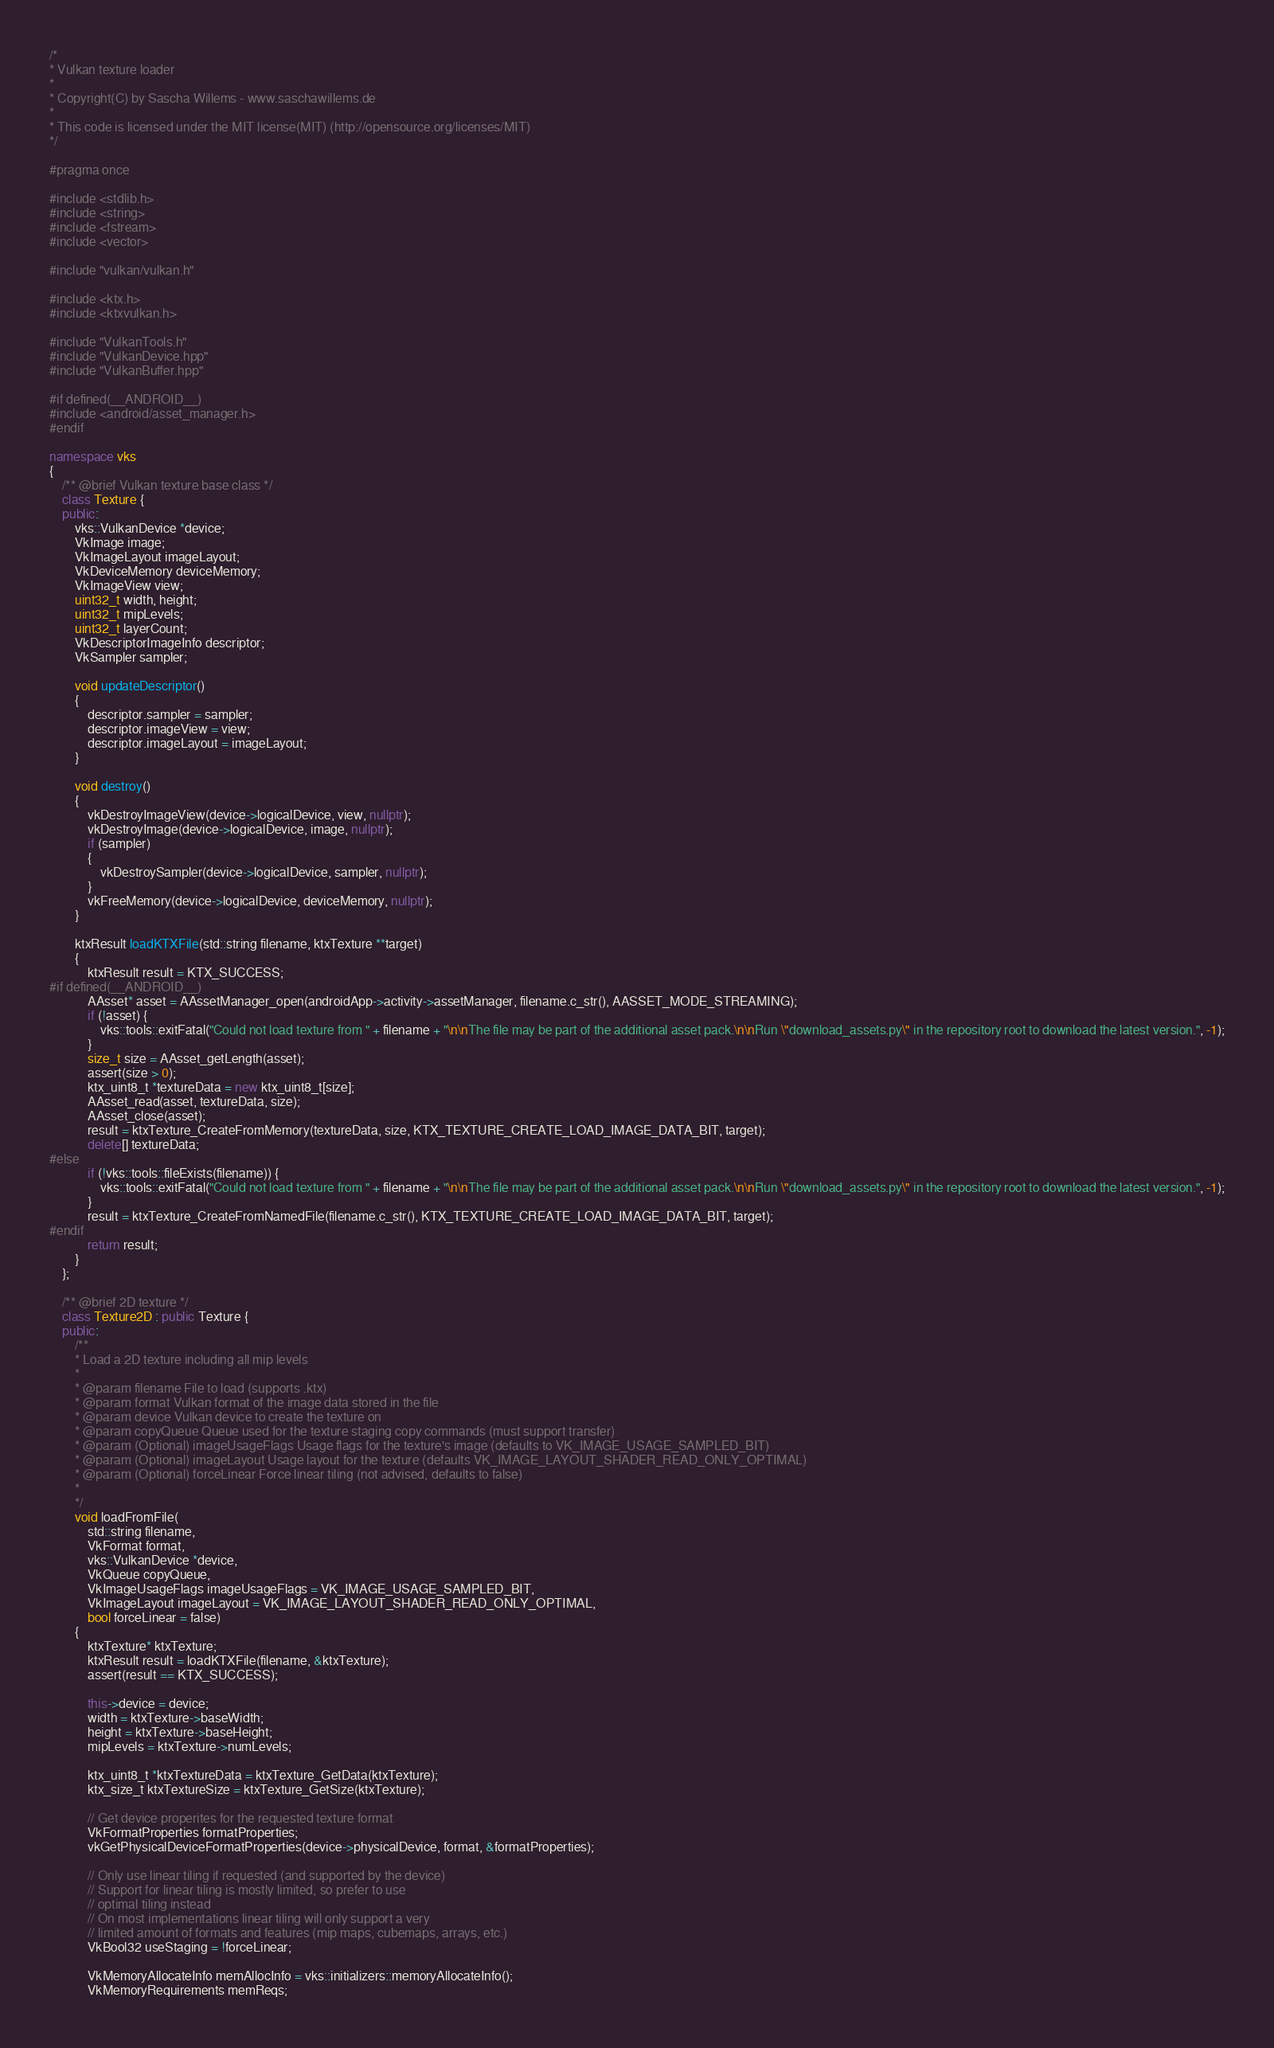Convert code to text. <code><loc_0><loc_0><loc_500><loc_500><_C++_>/*
* Vulkan texture loader
*
* Copyright(C) by Sascha Willems - www.saschawillems.de
*
* This code is licensed under the MIT license(MIT) (http://opensource.org/licenses/MIT)
*/

#pragma once

#include <stdlib.h>
#include <string>
#include <fstream>
#include <vector>

#include "vulkan/vulkan.h"

#include <ktx.h>
#include <ktxvulkan.h>

#include "VulkanTools.h"
#include "VulkanDevice.hpp"
#include "VulkanBuffer.hpp"

#if defined(__ANDROID__)
#include <android/asset_manager.h>
#endif

namespace vks
{
	/** @brief Vulkan texture base class */
	class Texture {
	public:
		vks::VulkanDevice *device;
		VkImage image;
		VkImageLayout imageLayout;
		VkDeviceMemory deviceMemory;
		VkImageView view;
		uint32_t width, height;
		uint32_t mipLevels;
		uint32_t layerCount;
		VkDescriptorImageInfo descriptor;
		VkSampler sampler;

		void updateDescriptor()
		{
			descriptor.sampler = sampler;
			descriptor.imageView = view;
			descriptor.imageLayout = imageLayout;
		}

		void destroy()
		{
			vkDestroyImageView(device->logicalDevice, view, nullptr);
			vkDestroyImage(device->logicalDevice, image, nullptr);
			if (sampler)
			{
				vkDestroySampler(device->logicalDevice, sampler, nullptr);
			}
			vkFreeMemory(device->logicalDevice, deviceMemory, nullptr);
		}

		ktxResult loadKTXFile(std::string filename, ktxTexture **target)
		{
			ktxResult result = KTX_SUCCESS;
#if defined(__ANDROID__)
			AAsset* asset = AAssetManager_open(androidApp->activity->assetManager, filename.c_str(), AASSET_MODE_STREAMING);
			if (!asset) {
				vks::tools::exitFatal("Could not load texture from " + filename + "\n\nThe file may be part of the additional asset pack.\n\nRun \"download_assets.py\" in the repository root to download the latest version.", -1);
			}
			size_t size = AAsset_getLength(asset);
			assert(size > 0);
			ktx_uint8_t *textureData = new ktx_uint8_t[size];
			AAsset_read(asset, textureData, size);
			AAsset_close(asset);
			result = ktxTexture_CreateFromMemory(textureData, size, KTX_TEXTURE_CREATE_LOAD_IMAGE_DATA_BIT, target);
			delete[] textureData;
#else
			if (!vks::tools::fileExists(filename)) {
				vks::tools::exitFatal("Could not load texture from " + filename + "\n\nThe file may be part of the additional asset pack.\n\nRun \"download_assets.py\" in the repository root to download the latest version.", -1);
			}
			result = ktxTexture_CreateFromNamedFile(filename.c_str(), KTX_TEXTURE_CREATE_LOAD_IMAGE_DATA_BIT, target);			
#endif		
			return result;
		}
	};

	/** @brief 2D texture */
	class Texture2D : public Texture {
	public:
		/**
		* Load a 2D texture including all mip levels
		*
		* @param filename File to load (supports .ktx)
		* @param format Vulkan format of the image data stored in the file
		* @param device Vulkan device to create the texture on
		* @param copyQueue Queue used for the texture staging copy commands (must support transfer)
		* @param (Optional) imageUsageFlags Usage flags for the texture's image (defaults to VK_IMAGE_USAGE_SAMPLED_BIT)
		* @param (Optional) imageLayout Usage layout for the texture (defaults VK_IMAGE_LAYOUT_SHADER_READ_ONLY_OPTIMAL)
		* @param (Optional) forceLinear Force linear tiling (not advised, defaults to false)
		*
		*/
		void loadFromFile(
			std::string filename, 
			VkFormat format,
			vks::VulkanDevice *device,
			VkQueue copyQueue,
			VkImageUsageFlags imageUsageFlags = VK_IMAGE_USAGE_SAMPLED_BIT,
			VkImageLayout imageLayout = VK_IMAGE_LAYOUT_SHADER_READ_ONLY_OPTIMAL, 
			bool forceLinear = false)
		{
			ktxTexture* ktxTexture;
			ktxResult result = loadKTXFile(filename, &ktxTexture);
			assert(result == KTX_SUCCESS);

			this->device = device;
			width = ktxTexture->baseWidth;
			height = ktxTexture->baseHeight;
			mipLevels = ktxTexture->numLevels;

			ktx_uint8_t *ktxTextureData = ktxTexture_GetData(ktxTexture);
			ktx_size_t ktxTextureSize = ktxTexture_GetSize(ktxTexture);

			// Get device properites for the requested texture format
			VkFormatProperties formatProperties;
			vkGetPhysicalDeviceFormatProperties(device->physicalDevice, format, &formatProperties);

			// Only use linear tiling if requested (and supported by the device)
			// Support for linear tiling is mostly limited, so prefer to use
			// optimal tiling instead
			// On most implementations linear tiling will only support a very
			// limited amount of formats and features (mip maps, cubemaps, arrays, etc.)
			VkBool32 useStaging = !forceLinear;

			VkMemoryAllocateInfo memAllocInfo = vks::initializers::memoryAllocateInfo();
			VkMemoryRequirements memReqs;
</code> 